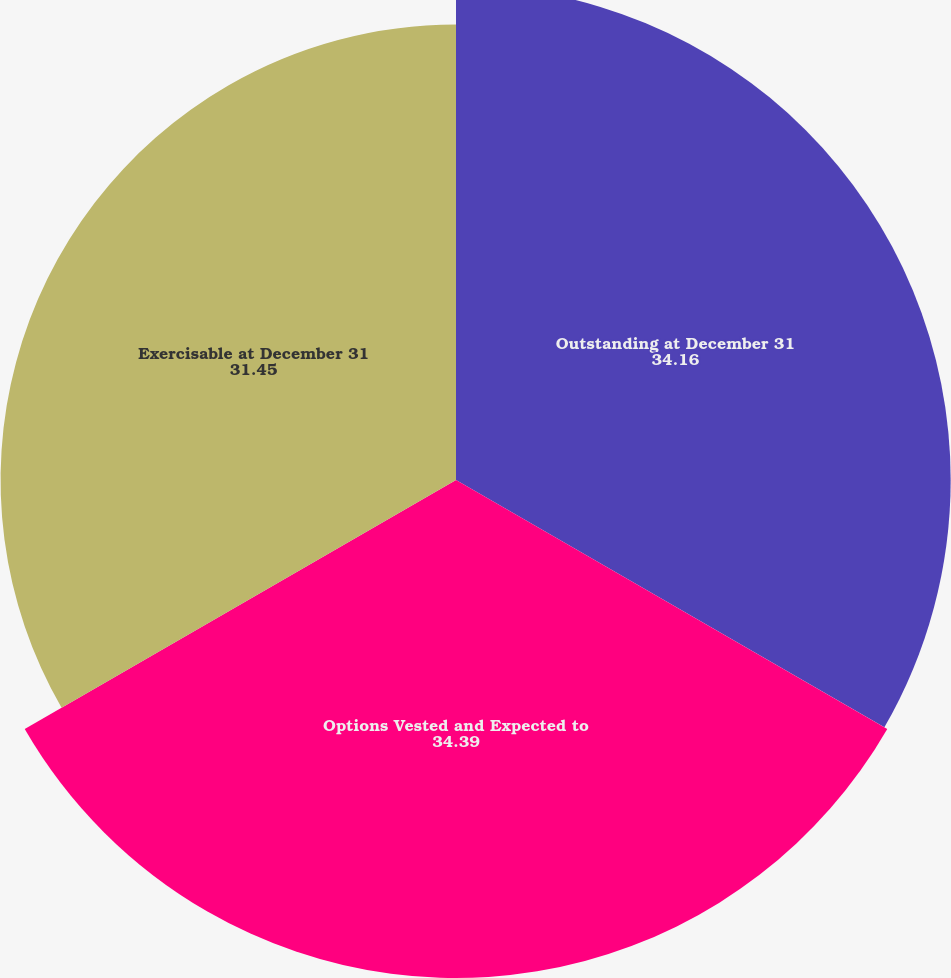<chart> <loc_0><loc_0><loc_500><loc_500><pie_chart><fcel>Outstanding at December 31<fcel>Options Vested and Expected to<fcel>Exercisable at December 31<nl><fcel>34.16%<fcel>34.39%<fcel>31.45%<nl></chart> 